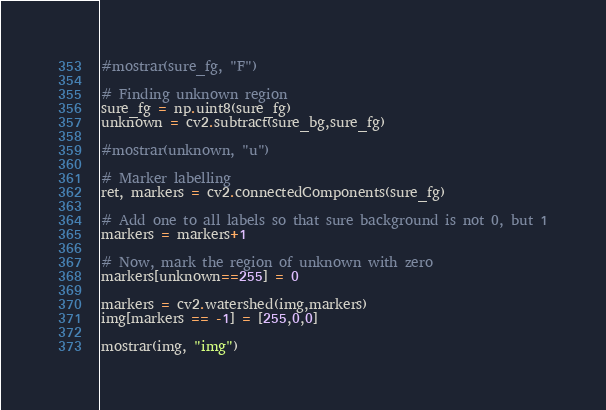Convert code to text. <code><loc_0><loc_0><loc_500><loc_500><_Python_>#mostrar(sure_fg, "F")

# Finding unknown region
sure_fg = np.uint8(sure_fg)
unknown = cv2.subtract(sure_bg,sure_fg)

#mostrar(unknown, "u")

# Marker labelling
ret, markers = cv2.connectedComponents(sure_fg)

# Add one to all labels so that sure background is not 0, but 1
markers = markers+1

# Now, mark the region of unknown with zero
markers[unknown==255] = 0

markers = cv2.watershed(img,markers)
img[markers == -1] = [255,0,0]

mostrar(img, "img")</code> 